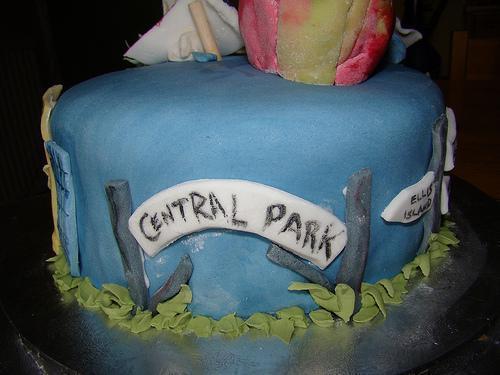How many cakes are shown?
Give a very brief answer. 1. 